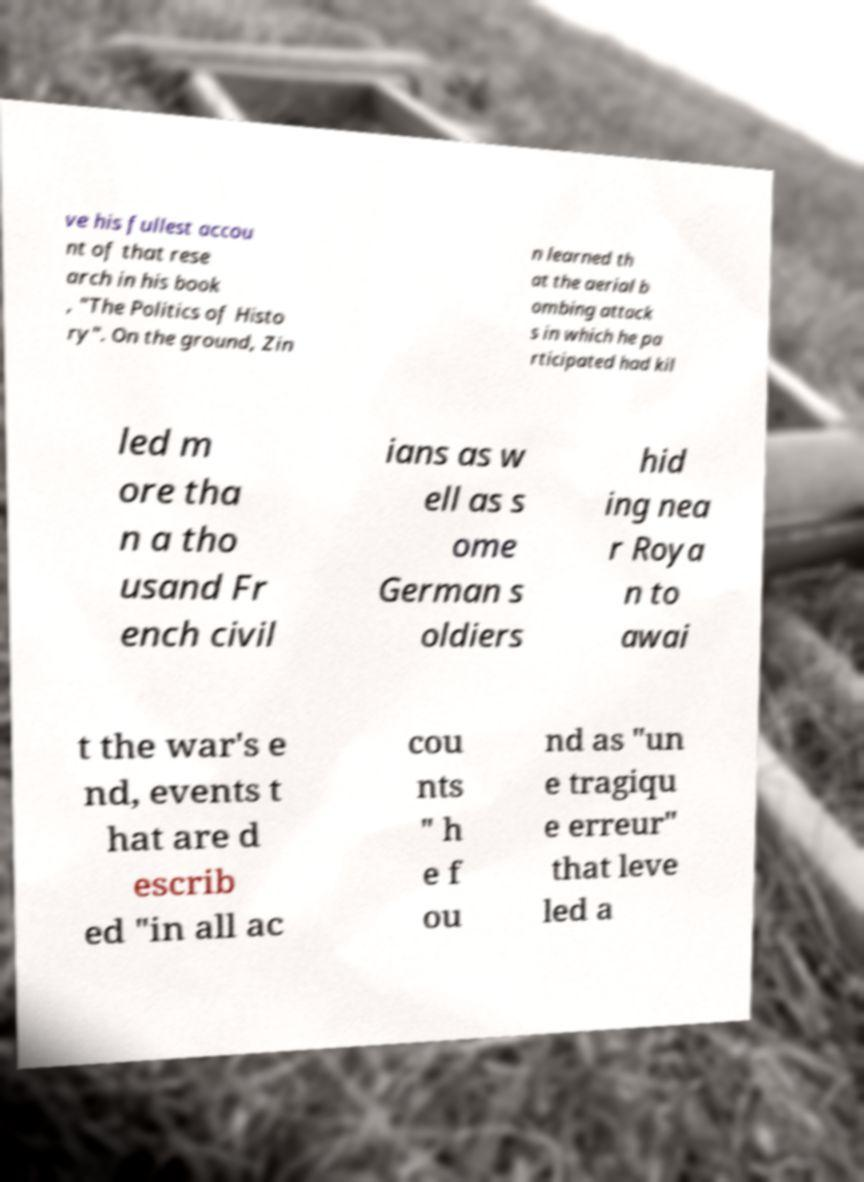What messages or text are displayed in this image? I need them in a readable, typed format. ve his fullest accou nt of that rese arch in his book , "The Politics of Histo ry". On the ground, Zin n learned th at the aerial b ombing attack s in which he pa rticipated had kil led m ore tha n a tho usand Fr ench civil ians as w ell as s ome German s oldiers hid ing nea r Roya n to awai t the war's e nd, events t hat are d escrib ed "in all ac cou nts " h e f ou nd as "un e tragiqu e erreur" that leve led a 